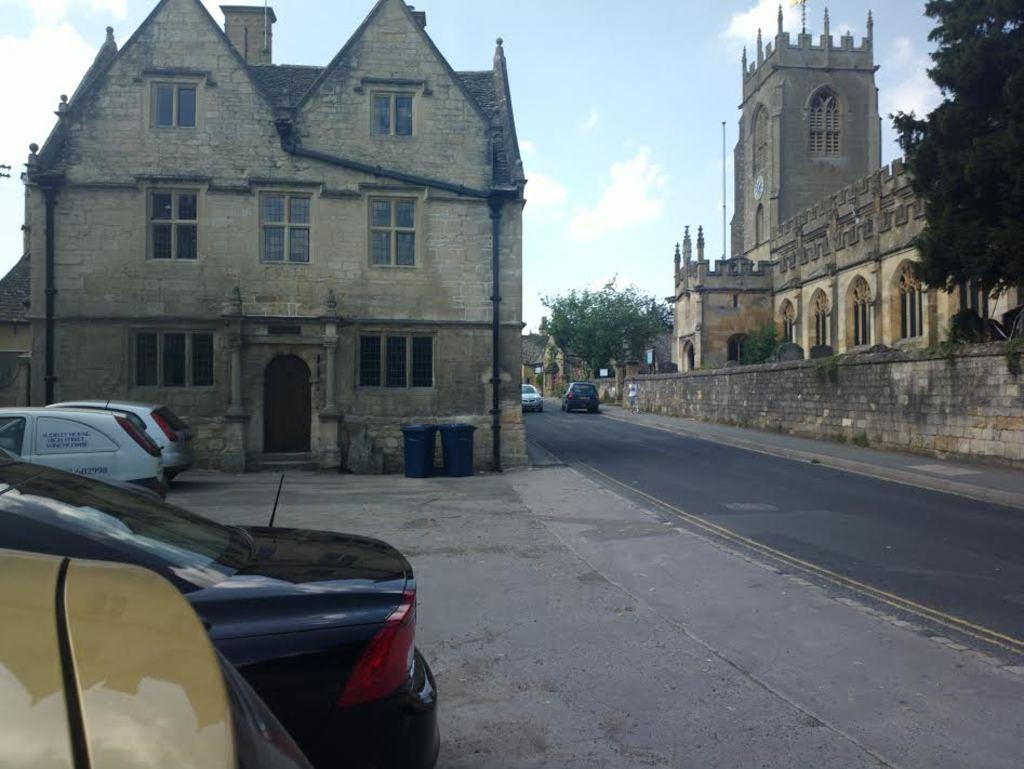In one or two sentences, can you explain what this image depicts? In this image, we can see some buildings, at the right side there is a green tree, we can see some cars, at the top there is a sky. 